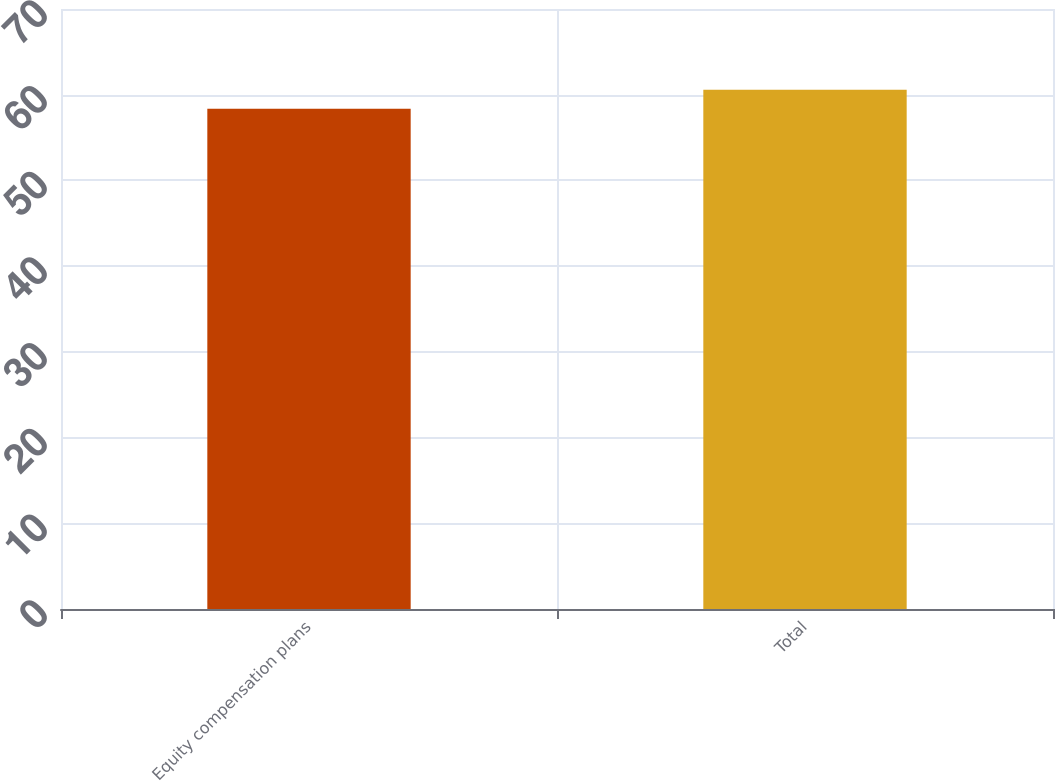Convert chart to OTSL. <chart><loc_0><loc_0><loc_500><loc_500><bar_chart><fcel>Equity compensation plans<fcel>Total<nl><fcel>58.35<fcel>60.57<nl></chart> 